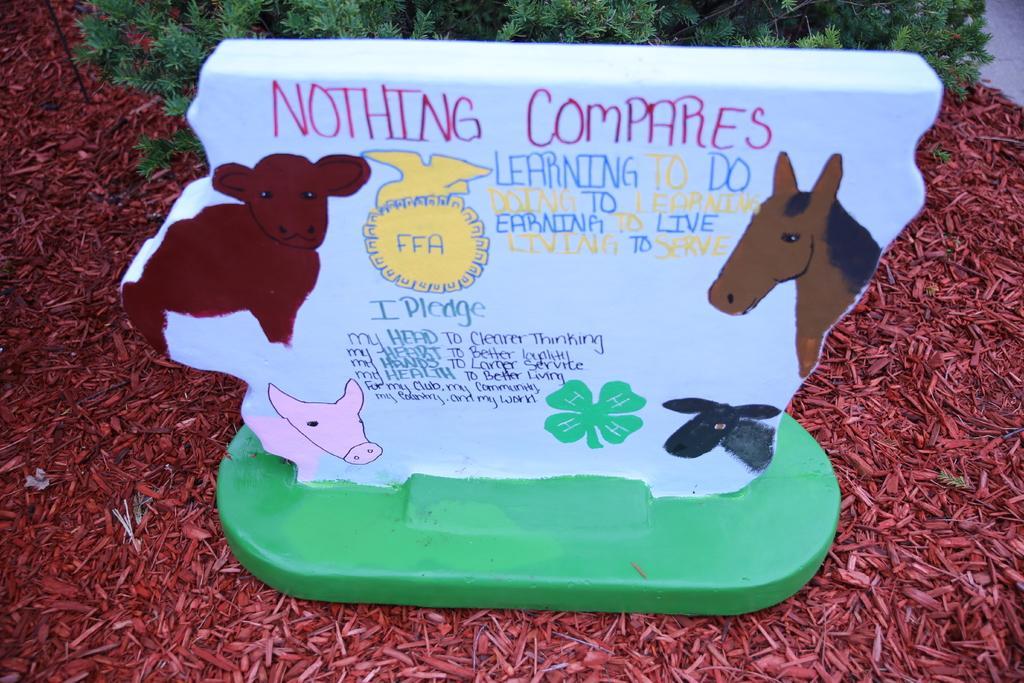Please provide a concise description of this image. In this image we can see a white color object on which we can see images of animals and some text here which is placed on the ground. In the background, we can see the plants. 